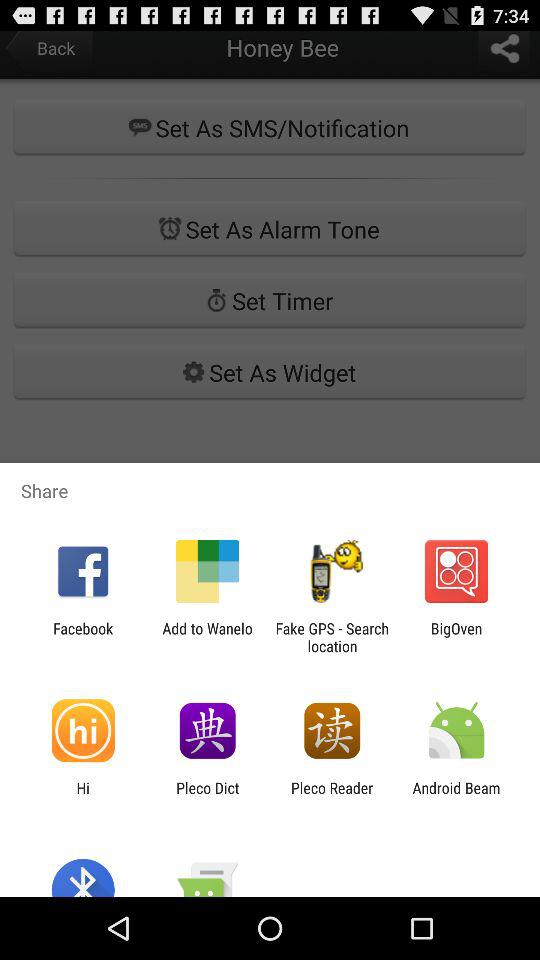For how many days is the alarm set?
When the provided information is insufficient, respond with <no answer>. <no answer> 